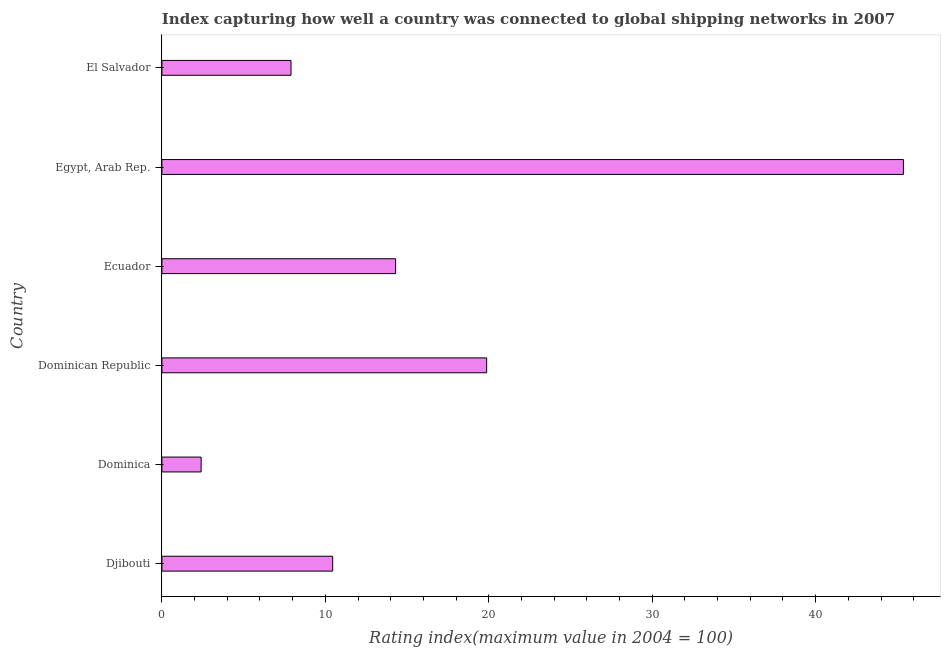Does the graph contain any zero values?
Make the answer very short. No. Does the graph contain grids?
Ensure brevity in your answer.  No. What is the title of the graph?
Make the answer very short. Index capturing how well a country was connected to global shipping networks in 2007. What is the label or title of the X-axis?
Your answer should be compact. Rating index(maximum value in 2004 = 100). What is the label or title of the Y-axis?
Offer a very short reply. Country. What is the liner shipping connectivity index in Dominican Republic?
Your answer should be very brief. 19.87. Across all countries, what is the maximum liner shipping connectivity index?
Your response must be concise. 45.37. In which country was the liner shipping connectivity index maximum?
Provide a short and direct response. Egypt, Arab Rep. In which country was the liner shipping connectivity index minimum?
Provide a short and direct response. Dominica. What is the sum of the liner shipping connectivity index?
Offer a very short reply. 100.29. What is the difference between the liner shipping connectivity index in Djibouti and Ecuador?
Provide a short and direct response. -3.85. What is the average liner shipping connectivity index per country?
Offer a terse response. 16.71. What is the median liner shipping connectivity index?
Your answer should be very brief. 12.38. In how many countries, is the liner shipping connectivity index greater than 32 ?
Provide a succinct answer. 1. What is the ratio of the liner shipping connectivity index in Djibouti to that in Egypt, Arab Rep.?
Offer a very short reply. 0.23. Is the liner shipping connectivity index in Dominica less than that in Egypt, Arab Rep.?
Offer a terse response. Yes. Is the difference between the liner shipping connectivity index in Dominican Republic and El Salvador greater than the difference between any two countries?
Provide a short and direct response. No. What is the difference between the highest and the second highest liner shipping connectivity index?
Offer a very short reply. 25.5. What is the difference between the highest and the lowest liner shipping connectivity index?
Offer a terse response. 42.97. In how many countries, is the liner shipping connectivity index greater than the average liner shipping connectivity index taken over all countries?
Offer a very short reply. 2. Are all the bars in the graph horizontal?
Your answer should be compact. Yes. What is the difference between two consecutive major ticks on the X-axis?
Your answer should be very brief. 10. What is the Rating index(maximum value in 2004 = 100) of Djibouti?
Ensure brevity in your answer.  10.45. What is the Rating index(maximum value in 2004 = 100) of Dominica?
Keep it short and to the point. 2.4. What is the Rating index(maximum value in 2004 = 100) of Dominican Republic?
Offer a very short reply. 19.87. What is the Rating index(maximum value in 2004 = 100) in Ecuador?
Ensure brevity in your answer.  14.3. What is the Rating index(maximum value in 2004 = 100) of Egypt, Arab Rep.?
Give a very brief answer. 45.37. What is the Rating index(maximum value in 2004 = 100) of El Salvador?
Ensure brevity in your answer.  7.9. What is the difference between the Rating index(maximum value in 2004 = 100) in Djibouti and Dominica?
Make the answer very short. 8.05. What is the difference between the Rating index(maximum value in 2004 = 100) in Djibouti and Dominican Republic?
Provide a succinct answer. -9.42. What is the difference between the Rating index(maximum value in 2004 = 100) in Djibouti and Ecuador?
Your answer should be very brief. -3.85. What is the difference between the Rating index(maximum value in 2004 = 100) in Djibouti and Egypt, Arab Rep.?
Keep it short and to the point. -34.92. What is the difference between the Rating index(maximum value in 2004 = 100) in Djibouti and El Salvador?
Provide a short and direct response. 2.55. What is the difference between the Rating index(maximum value in 2004 = 100) in Dominica and Dominican Republic?
Keep it short and to the point. -17.47. What is the difference between the Rating index(maximum value in 2004 = 100) in Dominica and Egypt, Arab Rep.?
Provide a succinct answer. -42.97. What is the difference between the Rating index(maximum value in 2004 = 100) in Dominican Republic and Ecuador?
Offer a terse response. 5.57. What is the difference between the Rating index(maximum value in 2004 = 100) in Dominican Republic and Egypt, Arab Rep.?
Offer a very short reply. -25.5. What is the difference between the Rating index(maximum value in 2004 = 100) in Dominican Republic and El Salvador?
Make the answer very short. 11.97. What is the difference between the Rating index(maximum value in 2004 = 100) in Ecuador and Egypt, Arab Rep.?
Your answer should be compact. -31.07. What is the difference between the Rating index(maximum value in 2004 = 100) in Egypt, Arab Rep. and El Salvador?
Your response must be concise. 37.47. What is the ratio of the Rating index(maximum value in 2004 = 100) in Djibouti to that in Dominica?
Offer a very short reply. 4.35. What is the ratio of the Rating index(maximum value in 2004 = 100) in Djibouti to that in Dominican Republic?
Your response must be concise. 0.53. What is the ratio of the Rating index(maximum value in 2004 = 100) in Djibouti to that in Ecuador?
Your response must be concise. 0.73. What is the ratio of the Rating index(maximum value in 2004 = 100) in Djibouti to that in Egypt, Arab Rep.?
Provide a succinct answer. 0.23. What is the ratio of the Rating index(maximum value in 2004 = 100) in Djibouti to that in El Salvador?
Ensure brevity in your answer.  1.32. What is the ratio of the Rating index(maximum value in 2004 = 100) in Dominica to that in Dominican Republic?
Give a very brief answer. 0.12. What is the ratio of the Rating index(maximum value in 2004 = 100) in Dominica to that in Ecuador?
Offer a terse response. 0.17. What is the ratio of the Rating index(maximum value in 2004 = 100) in Dominica to that in Egypt, Arab Rep.?
Give a very brief answer. 0.05. What is the ratio of the Rating index(maximum value in 2004 = 100) in Dominica to that in El Salvador?
Your answer should be very brief. 0.3. What is the ratio of the Rating index(maximum value in 2004 = 100) in Dominican Republic to that in Ecuador?
Your response must be concise. 1.39. What is the ratio of the Rating index(maximum value in 2004 = 100) in Dominican Republic to that in Egypt, Arab Rep.?
Provide a succinct answer. 0.44. What is the ratio of the Rating index(maximum value in 2004 = 100) in Dominican Republic to that in El Salvador?
Provide a short and direct response. 2.52. What is the ratio of the Rating index(maximum value in 2004 = 100) in Ecuador to that in Egypt, Arab Rep.?
Ensure brevity in your answer.  0.32. What is the ratio of the Rating index(maximum value in 2004 = 100) in Ecuador to that in El Salvador?
Provide a short and direct response. 1.81. What is the ratio of the Rating index(maximum value in 2004 = 100) in Egypt, Arab Rep. to that in El Salvador?
Keep it short and to the point. 5.74. 